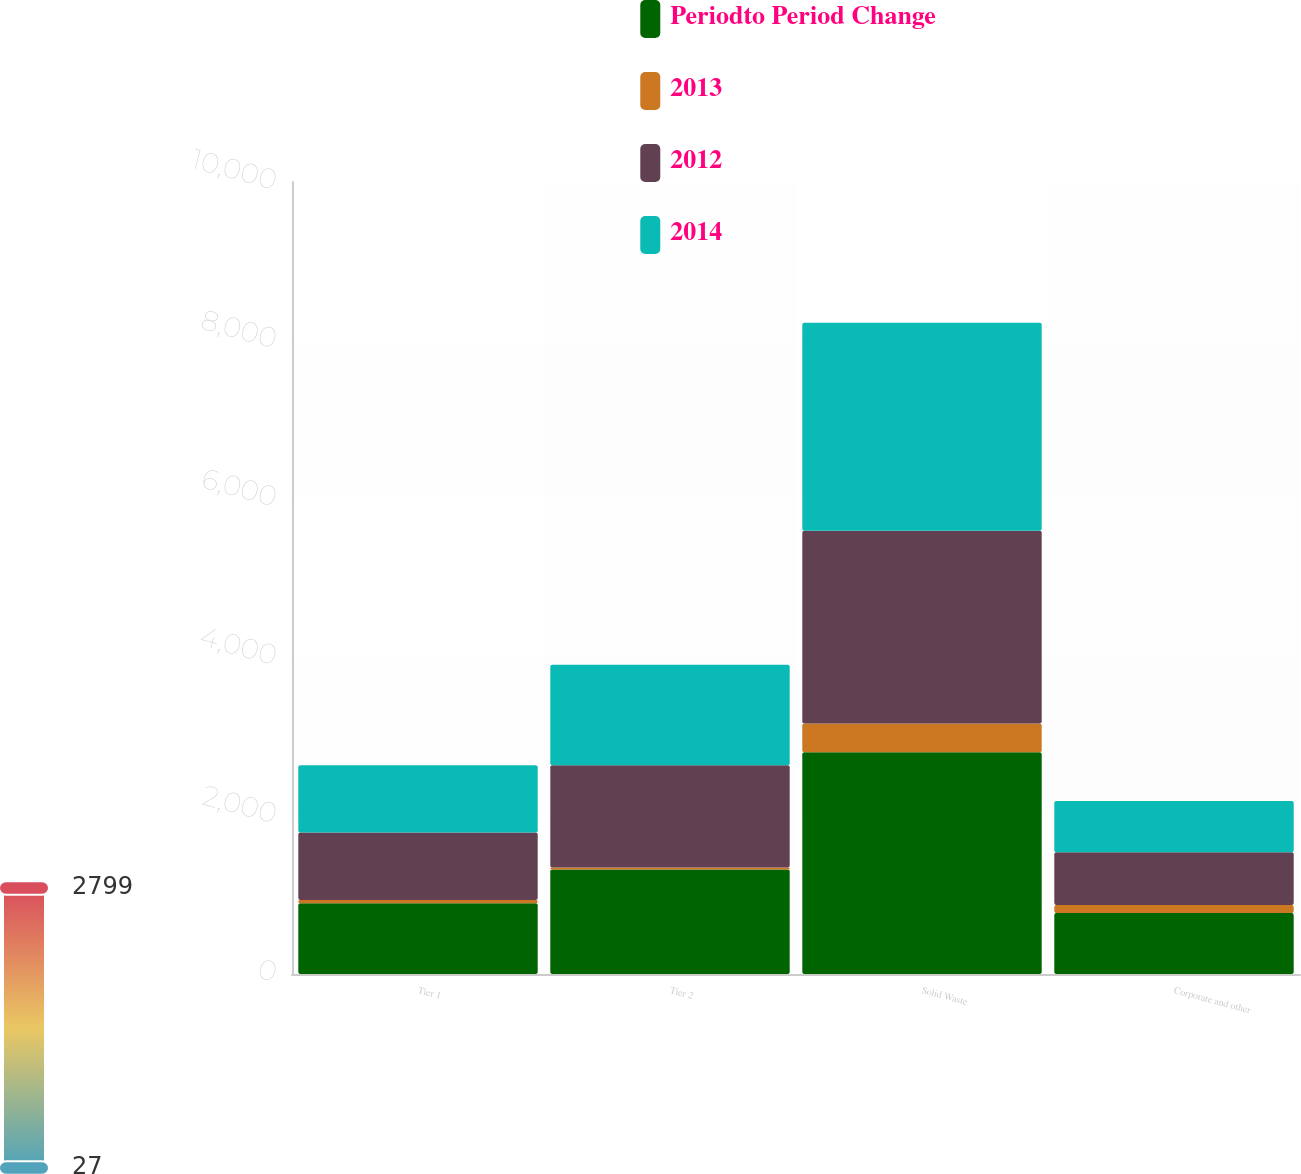Convert chart. <chart><loc_0><loc_0><loc_500><loc_500><stacked_bar_chart><ecel><fcel>Tier 1<fcel>Tier 2<fcel>Solid Waste<fcel>Corporate and other<nl><fcel>Periodto Period Change<fcel>893<fcel>1318<fcel>2799<fcel>769<nl><fcel>2013<fcel>41<fcel>27<fcel>365<fcel>102<nl><fcel>2012<fcel>852<fcel>1291<fcel>2434<fcel>667<nl><fcel>2014<fcel>851<fcel>1270<fcel>2625<fcel>645<nl></chart> 